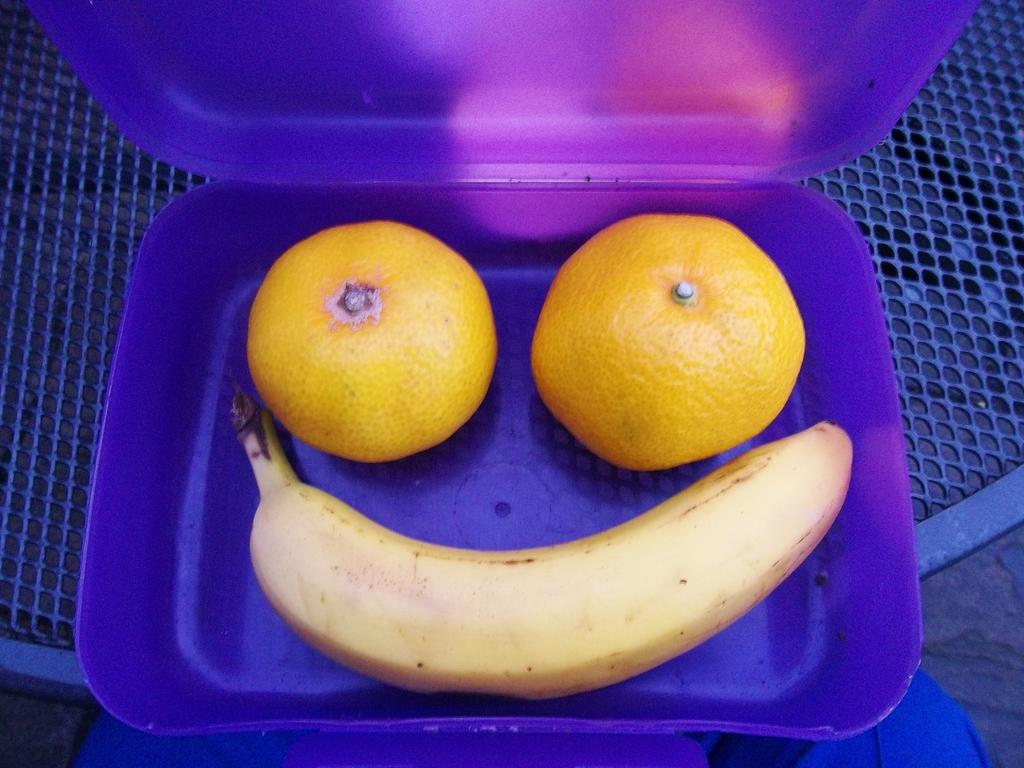What object is present on the table in the image? There is a plastic box on the table in the image. What is inside the plastic box? There are oranges and a banana in the plastic box. What type of juice can be seen spilled on the table in the image? There is no juice spilled on the table in the image; it only shows a plastic box with oranges and a banana. 